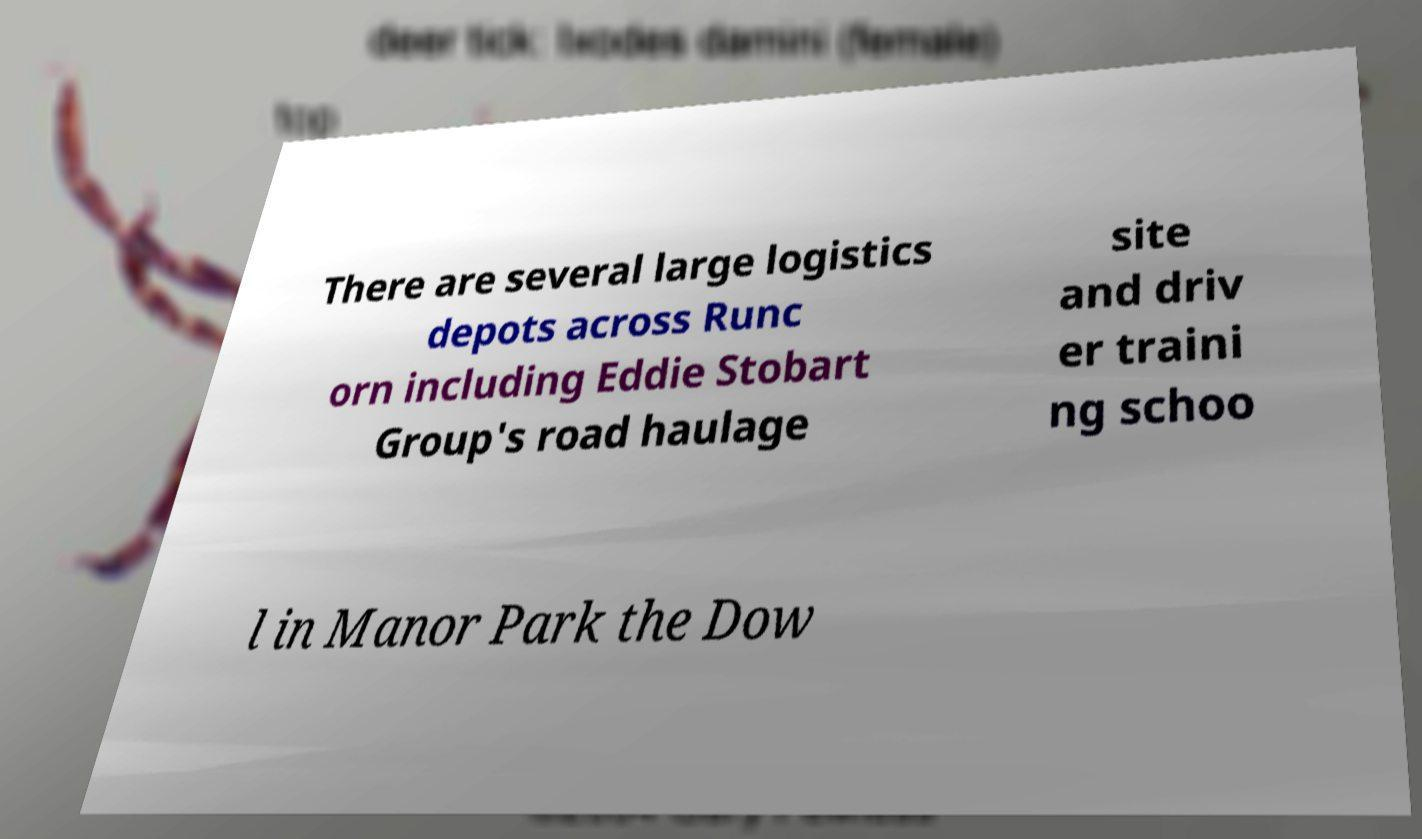Could you extract and type out the text from this image? There are several large logistics depots across Runc orn including Eddie Stobart Group's road haulage site and driv er traini ng schoo l in Manor Park the Dow 